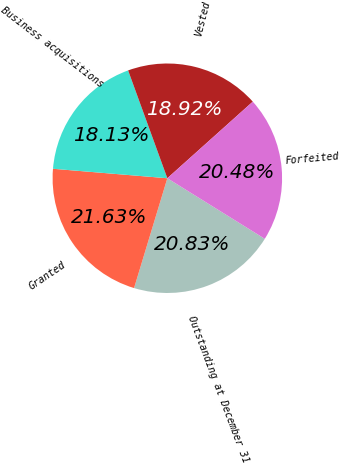Convert chart. <chart><loc_0><loc_0><loc_500><loc_500><pie_chart><fcel>Outstanding at December 31<fcel>Granted<fcel>Business acquisitions<fcel>Vested<fcel>Forfeited<nl><fcel>20.83%<fcel>21.63%<fcel>18.13%<fcel>18.92%<fcel>20.48%<nl></chart> 